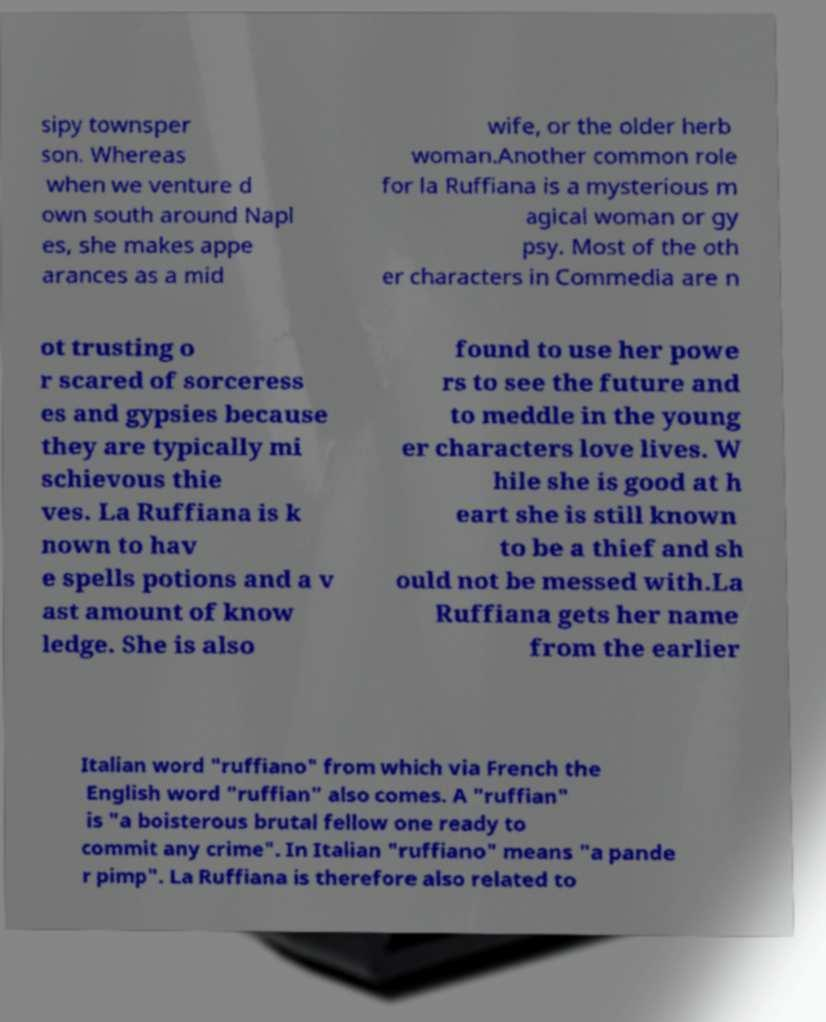I need the written content from this picture converted into text. Can you do that? sipy townsper son. Whereas when we venture d own south around Napl es, she makes appe arances as a mid wife, or the older herb woman.Another common role for la Ruffiana is a mysterious m agical woman or gy psy. Most of the oth er characters in Commedia are n ot trusting o r scared of sorceress es and gypsies because they are typically mi schievous thie ves. La Ruffiana is k nown to hav e spells potions and a v ast amount of know ledge. She is also found to use her powe rs to see the future and to meddle in the young er characters love lives. W hile she is good at h eart she is still known to be a thief and sh ould not be messed with.La Ruffiana gets her name from the earlier Italian word "ruffiano" from which via French the English word "ruffian" also comes. A "ruffian" is "a boisterous brutal fellow one ready to commit any crime". In Italian "ruffiano" means "a pande r pimp". La Ruffiana is therefore also related to 